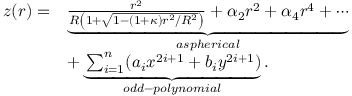<formula> <loc_0><loc_0><loc_500><loc_500>\begin{array} { r l } { z ( r ) = } & { \underbrace { \frac { r ^ { 2 } } { R \left ( 1 + \sqrt { 1 - ( 1 + \kappa ) r ^ { 2 } / R ^ { 2 } } \right ) } + \alpha _ { 2 } r ^ { 2 } + \alpha _ { 4 } r ^ { 4 } + \cdots } _ { a s p h e r i c a l } } \\ & { + \underbrace { \sum _ { i = 1 } ^ { n } ( a _ { i } x ^ { 2 i + 1 } + b _ { i } y ^ { 2 i + 1 } ) } _ { o d d - p o l y n o m i a l } . } \end{array}</formula> 